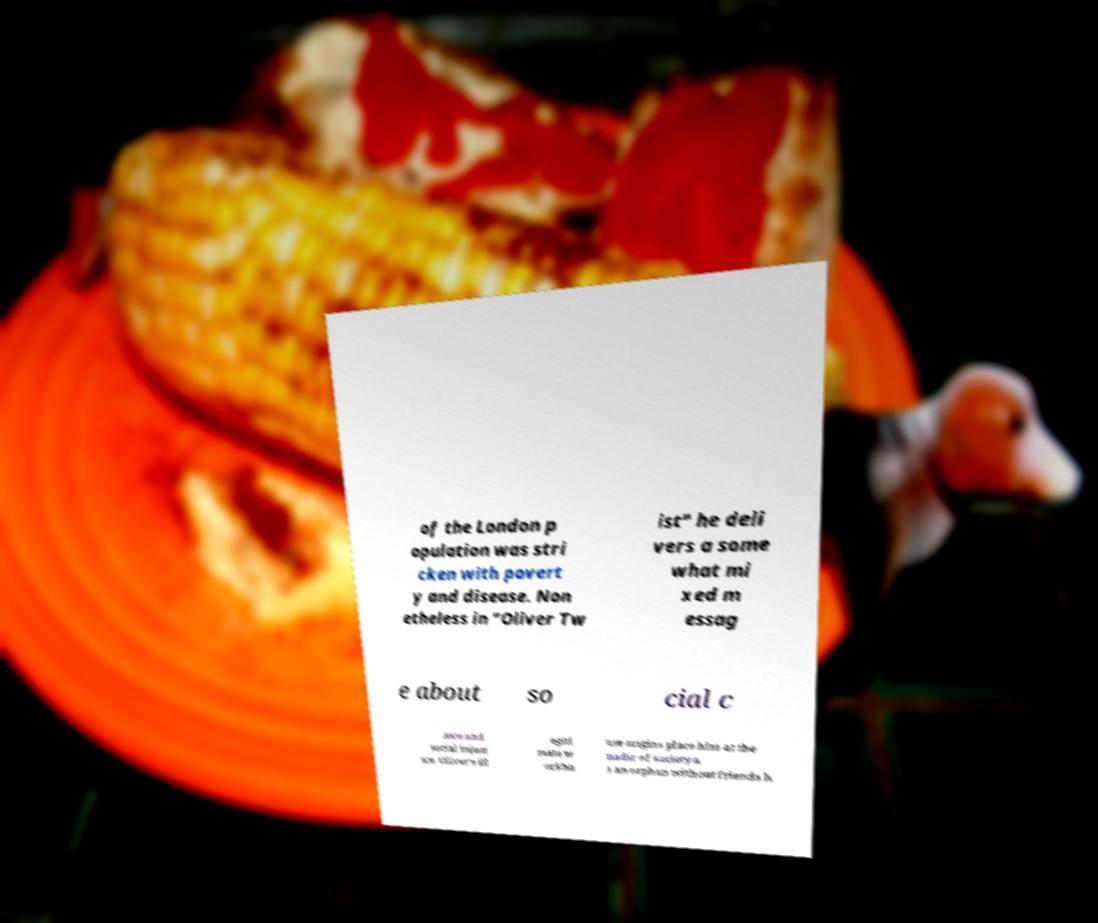Could you extract and type out the text from this image? of the London p opulation was stri cken with povert y and disease. Non etheless in "Oliver Tw ist" he deli vers a some what mi xed m essag e about so cial c aste and social injust ice. Oliver's ill egiti mate w orkho use origins place him at the nadir of society a s an orphan without friends h 